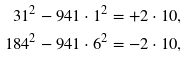Convert formula to latex. <formula><loc_0><loc_0><loc_500><loc_500>3 1 ^ { 2 } - 9 4 1 \cdot 1 ^ { 2 } & = + 2 \cdot 1 0 , \\ 1 8 4 ^ { 2 } - 9 4 1 \cdot 6 ^ { 2 } & = - 2 \cdot 1 0 ,</formula> 